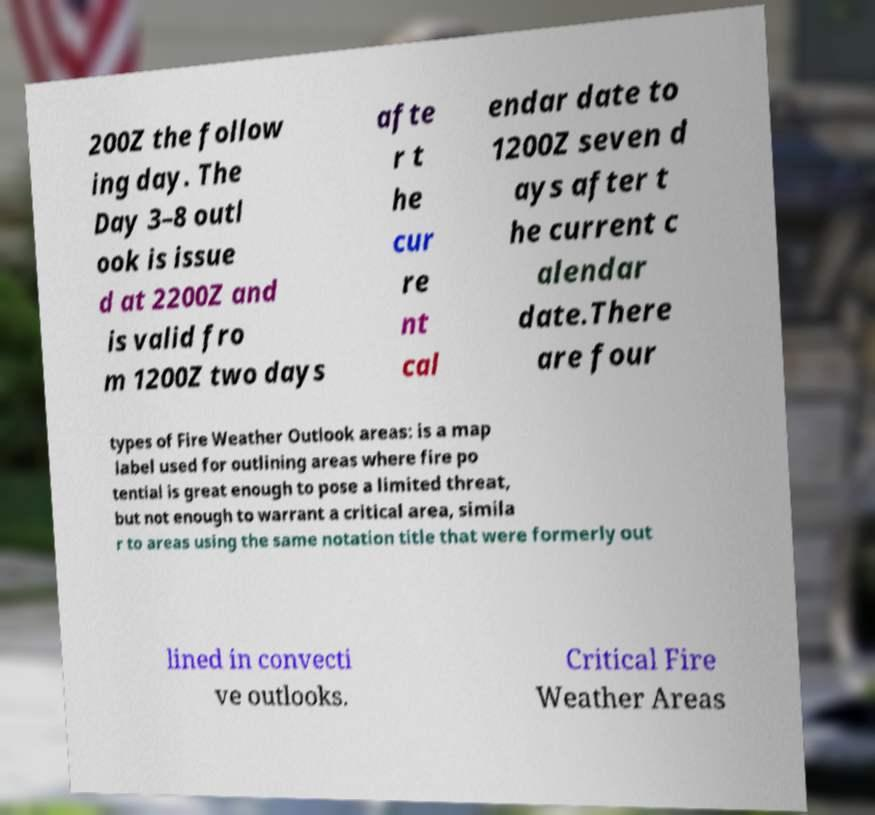Can you read and provide the text displayed in the image?This photo seems to have some interesting text. Can you extract and type it out for me? 200Z the follow ing day. The Day 3–8 outl ook is issue d at 2200Z and is valid fro m 1200Z two days afte r t he cur re nt cal endar date to 1200Z seven d ays after t he current c alendar date.There are four types of Fire Weather Outlook areas: is a map label used for outlining areas where fire po tential is great enough to pose a limited threat, but not enough to warrant a critical area, simila r to areas using the same notation title that were formerly out lined in convecti ve outlooks. Critical Fire Weather Areas 